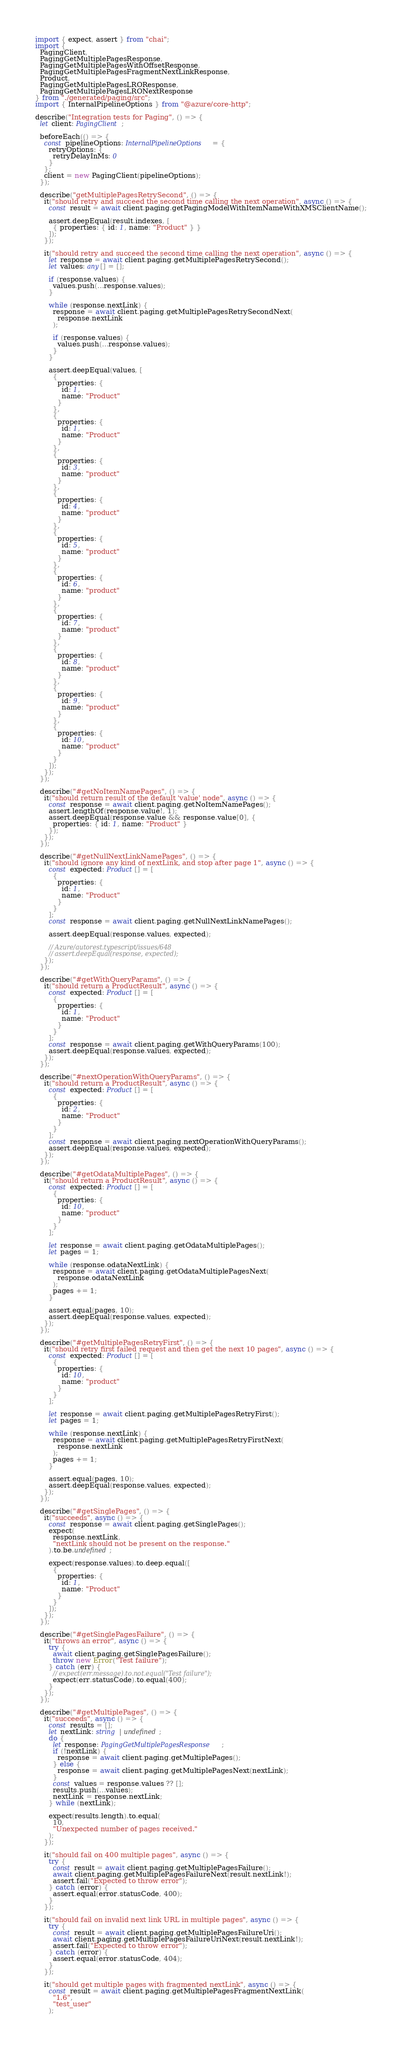Convert code to text. <code><loc_0><loc_0><loc_500><loc_500><_TypeScript_>import { expect, assert } from "chai";
import {
  PagingClient,
  PagingGetMultiplePagesResponse,
  PagingGetMultiplePagesWithOffsetResponse,
  PagingGetMultiplePagesFragmentNextLinkResponse,
  Product,
  PagingGetMultiplePagesLROResponse,
  PagingGetMultiplePagesLRONextResponse
} from "./generated/paging/src";
import { InternalPipelineOptions } from "@azure/core-http";

describe("Integration tests for Paging", () => {
  let client: PagingClient;

  beforeEach(() => {
    const pipelineOptions: InternalPipelineOptions = {
      retryOptions: {
        retryDelayInMs: 0
      }
    };
    client = new PagingClient(pipelineOptions);
  });

  describe("getMultiplePagesRetrySecond", () => {
    it("should retry and succeed the second time calling the next operation", async () => {
      const result = await client.paging.getPagingModelWithItemNameWithXMSClientName();

      assert.deepEqual(result.indexes, [
        { properties: { id: 1, name: "Product" } }
      ]);
    });

    it("should retry and succeed the second time calling the next operation", async () => {
      let response = await client.paging.getMultiplePagesRetrySecond();
      let values: any[] = [];

      if (response.values) {
        values.push(...response.values);
      }

      while (response.nextLink) {
        response = await client.paging.getMultiplePagesRetrySecondNext(
          response.nextLink
        );

        if (response.values) {
          values.push(...response.values);
        }
      }

      assert.deepEqual(values, [
        {
          properties: {
            id: 1,
            name: "Product"
          }
        },
        {
          properties: {
            id: 1,
            name: "Product"
          }
        },
        {
          properties: {
            id: 3,
            name: "product"
          }
        },
        {
          properties: {
            id: 4,
            name: "product"
          }
        },
        {
          properties: {
            id: 5,
            name: "product"
          }
        },
        {
          properties: {
            id: 6,
            name: "product"
          }
        },
        {
          properties: {
            id: 7,
            name: "product"
          }
        },
        {
          properties: {
            id: 8,
            name: "product"
          }
        },
        {
          properties: {
            id: 9,
            name: "product"
          }
        },
        {
          properties: {
            id: 10,
            name: "product"
          }
        }
      ]);
    });
  });

  describe("#getNoItemNamePages", () => {
    it("should return result of the default 'value' node", async () => {
      const response = await client.paging.getNoItemNamePages();
      assert.lengthOf(response.value!, 1);
      assert.deepEqual(response.value && response.value[0], {
        properties: { id: 1, name: "Product" }
      });
    });
  });

  describe("#getNullNextLinkNamePages", () => {
    it("should ignore any kind of nextLink, and stop after page 1", async () => {
      const expected: Product[] = [
        {
          properties: {
            id: 1,
            name: "Product"
          }
        }
      ];
      const response = await client.paging.getNullNextLinkNamePages();

      assert.deepEqual(response.values, expected);

      // Azure/autorest.typescript/issues/648
      // assert.deepEqual(response, expected);
    });
  });

  describe("#getWithQueryParams", () => {
    it("should return a ProductResult", async () => {
      const expected: Product[] = [
        {
          properties: {
            id: 1,
            name: "Product"
          }
        }
      ];
      const response = await client.paging.getWithQueryParams(100);
      assert.deepEqual(response.values, expected);
    });
  });

  describe("#nextOperationWithQueryParams", () => {
    it("should return a ProductResult", async () => {
      const expected: Product[] = [
        {
          properties: {
            id: 2,
            name: "Product"
          }
        }
      ];
      const response = await client.paging.nextOperationWithQueryParams();
      assert.deepEqual(response.values, expected);
    });
  });

  describe("#getOdataMultiplePages", () => {
    it("should return a ProductResult", async () => {
      const expected: Product[] = [
        {
          properties: {
            id: 10,
            name: "product"
          }
        }
      ];

      let response = await client.paging.getOdataMultiplePages();
      let pages = 1;

      while (response.odataNextLink) {
        response = await client.paging.getOdataMultiplePagesNext(
          response.odataNextLink
        );
        pages += 1;
      }

      assert.equal(pages, 10);
      assert.deepEqual(response.values, expected);
    });
  });

  describe("#getMultiplePagesRetryFirst", () => {
    it("should retry first failed request and then get the next 10 pages", async () => {
      const expected: Product[] = [
        {
          properties: {
            id: 10,
            name: "product"
          }
        }
      ];

      let response = await client.paging.getMultiplePagesRetryFirst();
      let pages = 1;

      while (response.nextLink) {
        response = await client.paging.getMultiplePagesRetryFirstNext(
          response.nextLink
        );
        pages += 1;
      }

      assert.equal(pages, 10);
      assert.deepEqual(response.values, expected);
    });
  });

  describe("#getSinglePages", () => {
    it("succeeds", async () => {
      const response = await client.paging.getSinglePages();
      expect(
        response.nextLink,
        "nextLink should not be present on the response."
      ).to.be.undefined;

      expect(response.values).to.deep.equal([
        {
          properties: {
            id: 1,
            name: "Product"
          }
        }
      ]);
    });
  });

  describe("#getSinglePagesFailure", () => {
    it("throws an error", async () => {
      try {
        await client.paging.getSinglePagesFailure();
        throw new Error("Test failure");
      } catch (err) {
        // expect(err.message).to.not.equal("Test failure");
        expect(err.statusCode).to.equal(400);
      }
    });
  });

  describe("#getMultiplePages", () => {
    it("succeeds", async () => {
      const results = [];
      let nextLink: string | undefined;
      do {
        let response: PagingGetMultiplePagesResponse;
        if (!nextLink) {
          response = await client.paging.getMultiplePages();
        } else {
          response = await client.paging.getMultiplePagesNext(nextLink);
        }
        const values = response.values ?? [];
        results.push(...values);
        nextLink = response.nextLink;
      } while (nextLink);

      expect(results.length).to.equal(
        10,
        "Unexpected number of pages received."
      );
    });

    it("should fail on 400 multiple pages", async () => {
      try {
        const result = await client.paging.getMultiplePagesFailure();
        await client.paging.getMultiplePagesFailureNext(result.nextLink!);
        assert.fail("Expected to throw error");
      } catch (error) {
        assert.equal(error.statusCode, 400);
      }
    });

    it("should fail on invalid next link URL in multiple pages", async () => {
      try {
        const result = await client.paging.getMultiplePagesFailureUri();
        await client.paging.getMultiplePagesFailureUriNext(result.nextLink!);
        assert.fail("Expected to throw error");
      } catch (error) {
        assert.equal(error.statusCode, 404);
      }
    });

    it("should get multiple pages with fragmented nextLink", async () => {
      const result = await client.paging.getMultiplePagesFragmentNextLink(
        "1.6",
        "test_user"
      );</code> 